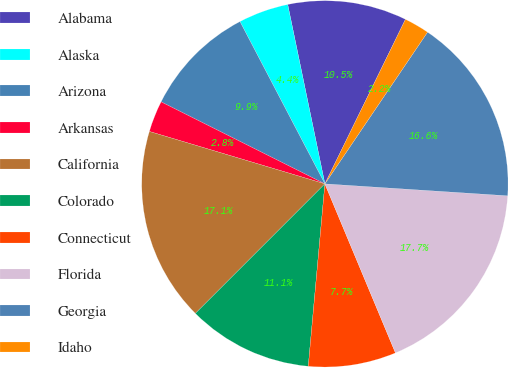Convert chart to OTSL. <chart><loc_0><loc_0><loc_500><loc_500><pie_chart><fcel>Alabama<fcel>Alaska<fcel>Arizona<fcel>Arkansas<fcel>California<fcel>Colorado<fcel>Connecticut<fcel>Florida<fcel>Georgia<fcel>Idaho<nl><fcel>10.5%<fcel>4.42%<fcel>9.94%<fcel>2.77%<fcel>17.12%<fcel>11.05%<fcel>7.74%<fcel>17.67%<fcel>16.57%<fcel>2.22%<nl></chart> 